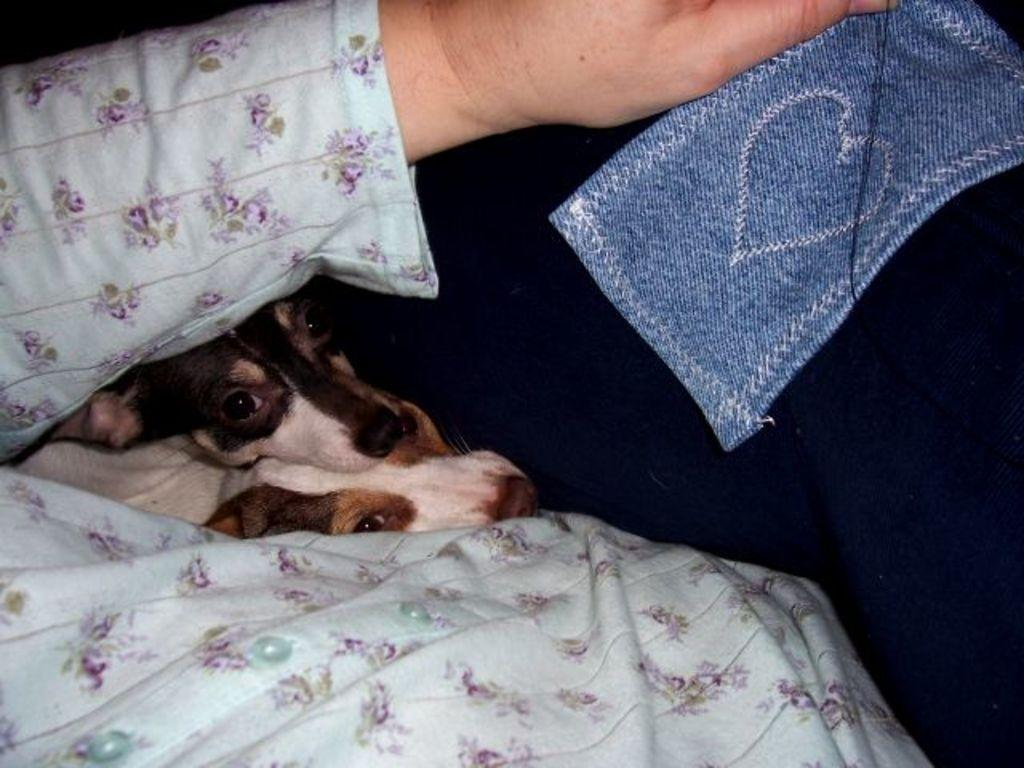What is the person in the image doing? The person is sitting in the image. What is the person holding in the image? The person is holding a cloth. What other living beings are present in the image? There are puppies in the image. What type of industry can be seen in the background of the image? There is no industry present in the image; it only features a person sitting, holding a cloth, and puppies. Is there any quicksand visible in the image? There is no quicksand present in the image. 